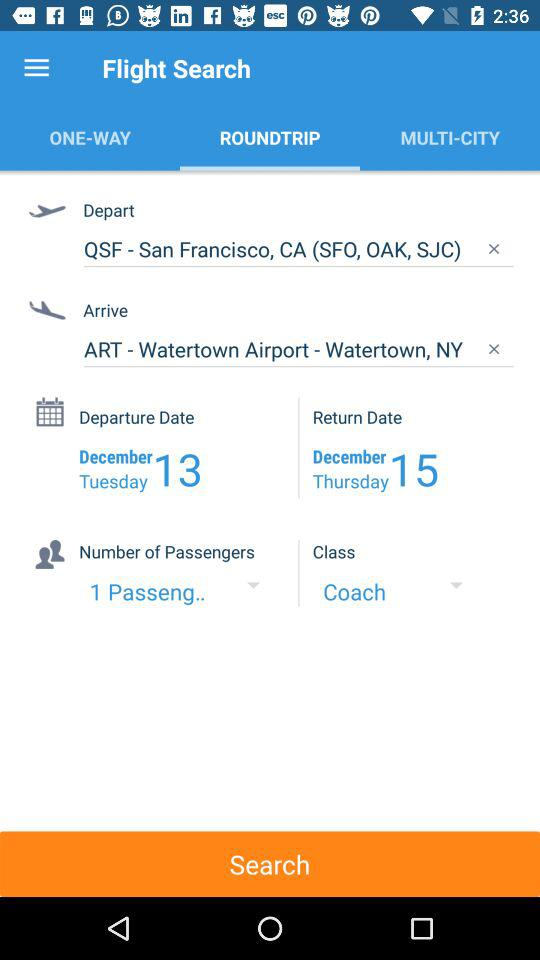How many more days are between the departure and return dates?
Answer the question using a single word or phrase. 2 